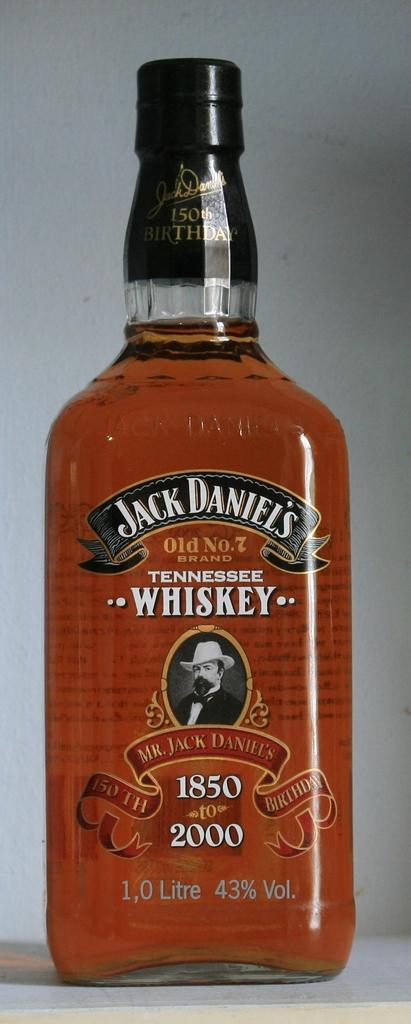What brand whiskey is in the bottle?
Provide a succinct answer. Jack daniels. What kind of beverage is in the bottle?
Your answer should be very brief. Whiskey. 